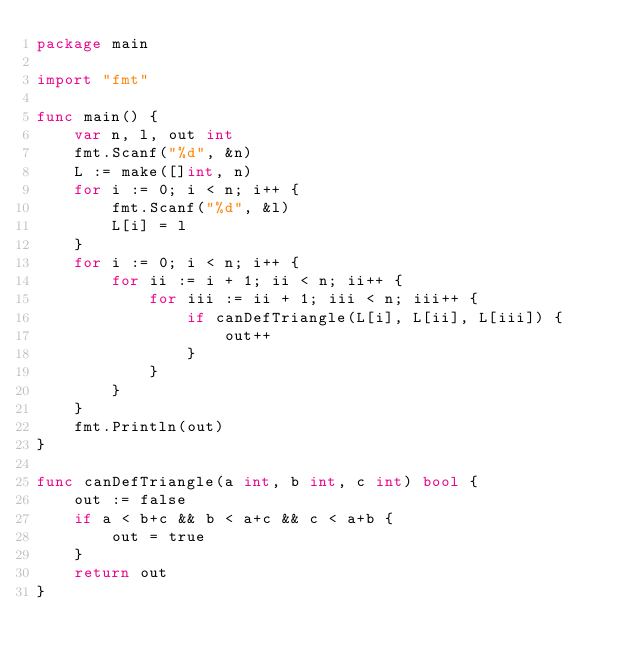<code> <loc_0><loc_0><loc_500><loc_500><_Go_>package main

import "fmt"

func main() {
	var n, l, out int
	fmt.Scanf("%d", &n)
	L := make([]int, n)
	for i := 0; i < n; i++ {
		fmt.Scanf("%d", &l)
		L[i] = l
	}
	for i := 0; i < n; i++ {
		for ii := i + 1; ii < n; ii++ {
			for iii := ii + 1; iii < n; iii++ {
				if canDefTriangle(L[i], L[ii], L[iii]) {
					out++
				}
			}
		}
	}
	fmt.Println(out)
}

func canDefTriangle(a int, b int, c int) bool {
	out := false
	if a < b+c && b < a+c && c < a+b {
		out = true
	}
	return out
}
</code> 